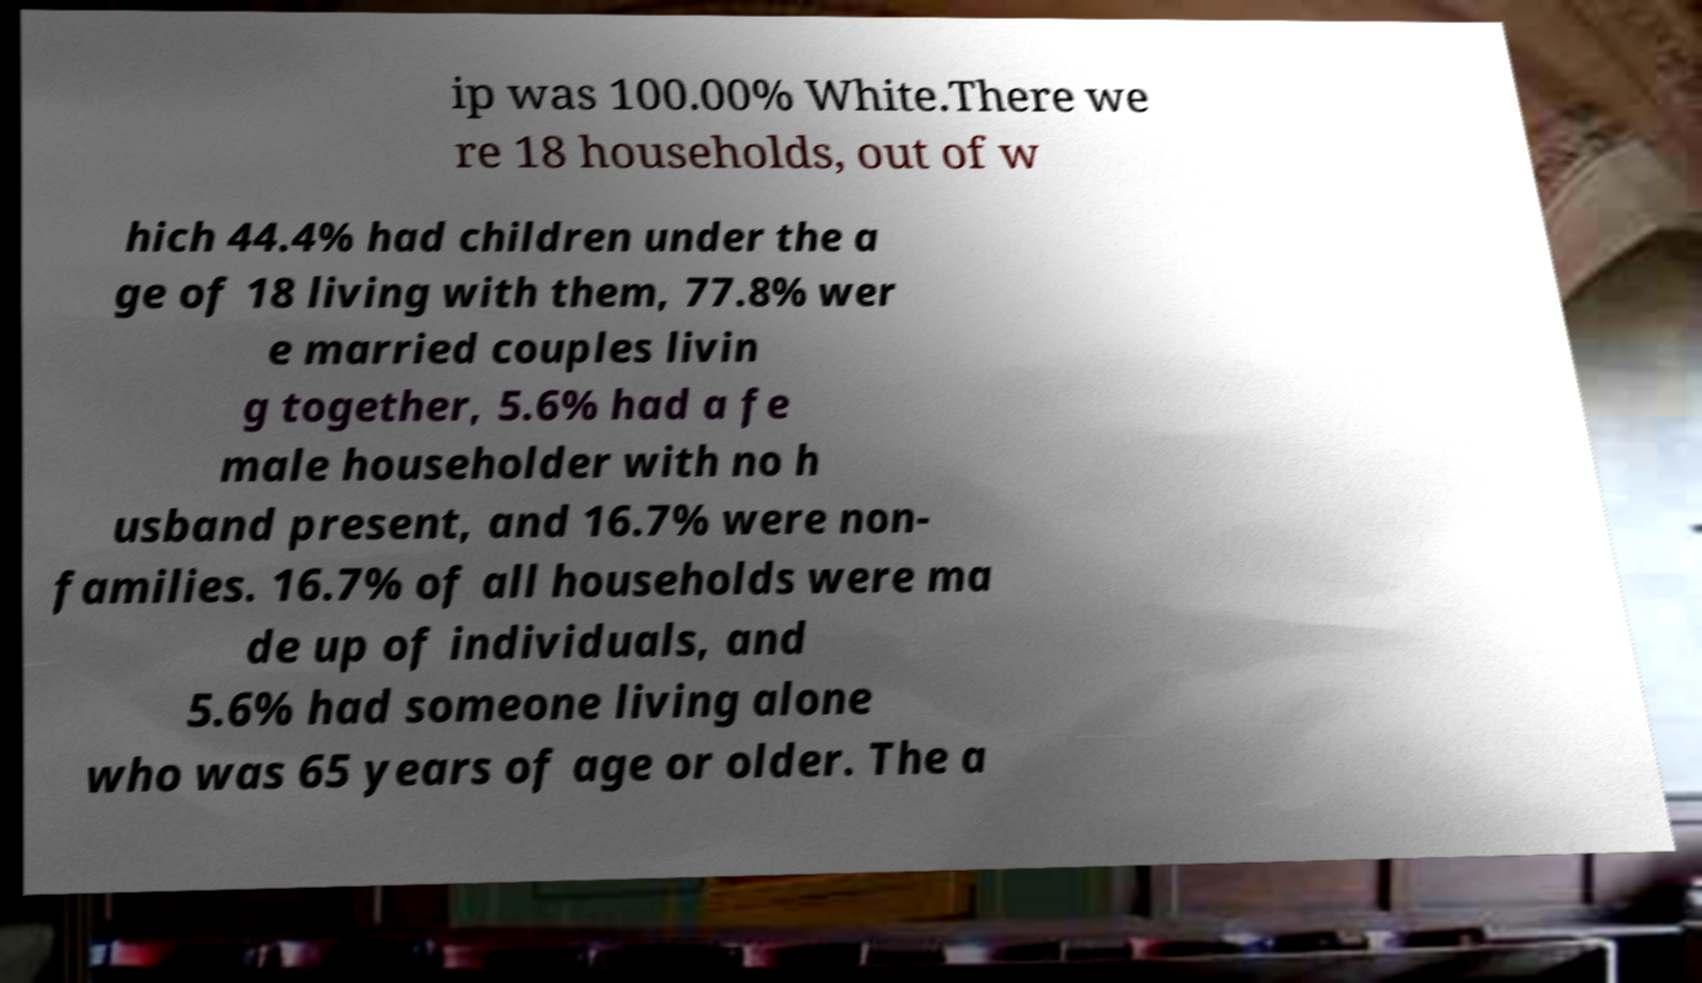Can you accurately transcribe the text from the provided image for me? ip was 100.00% White.There we re 18 households, out of w hich 44.4% had children under the a ge of 18 living with them, 77.8% wer e married couples livin g together, 5.6% had a fe male householder with no h usband present, and 16.7% were non- families. 16.7% of all households were ma de up of individuals, and 5.6% had someone living alone who was 65 years of age or older. The a 